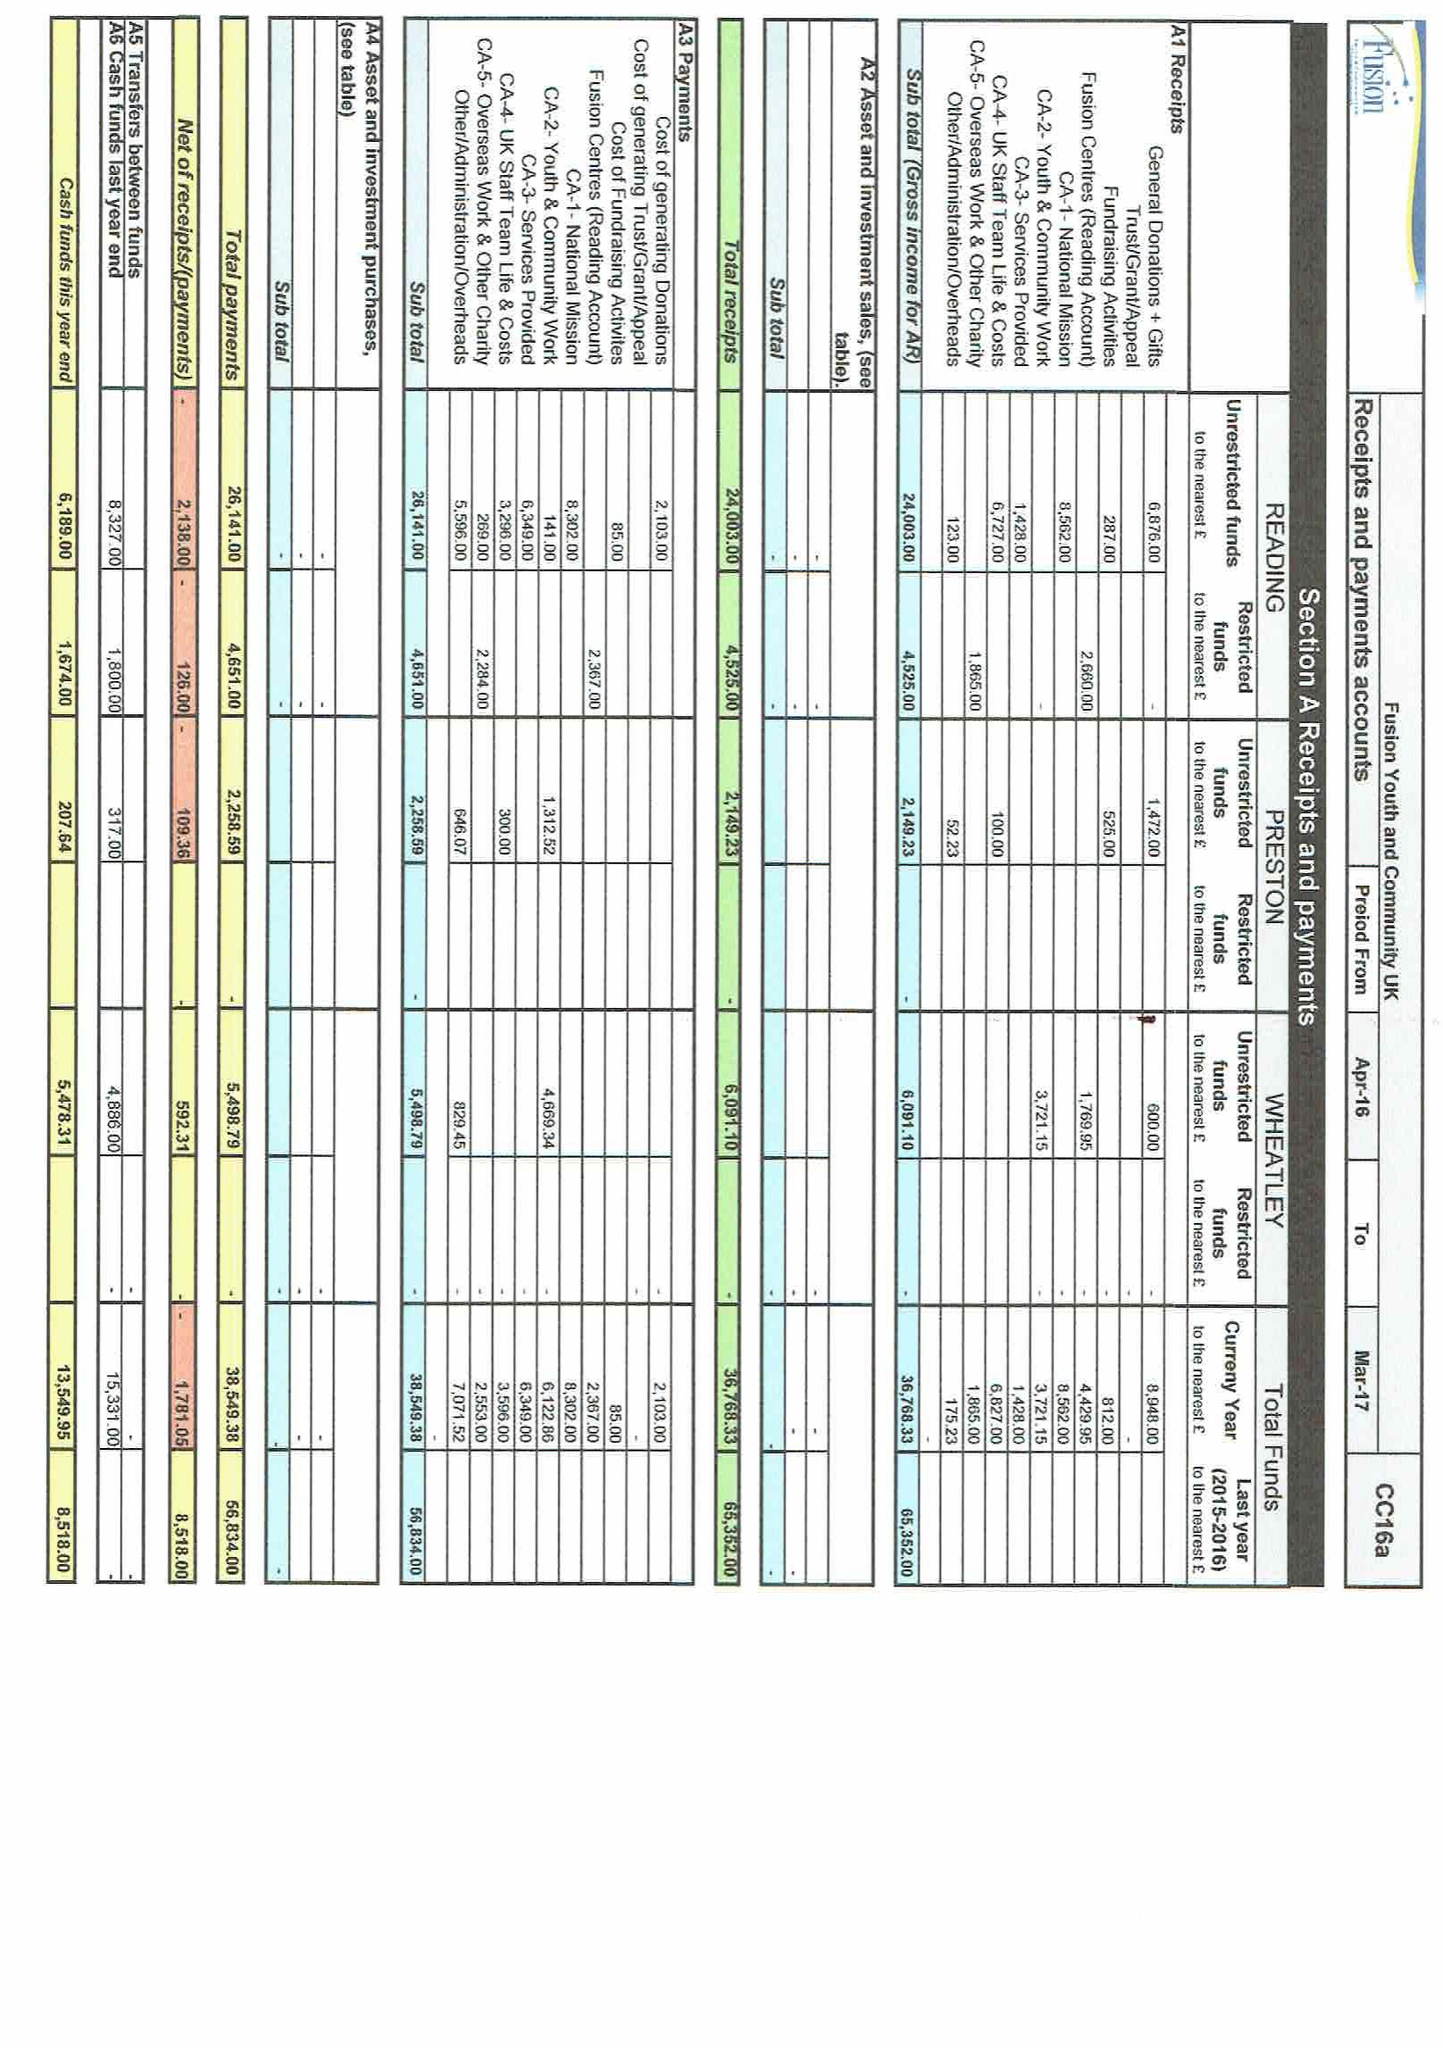What is the value for the charity_name?
Answer the question using a single word or phrase. Fusion Youth and Community Uk 